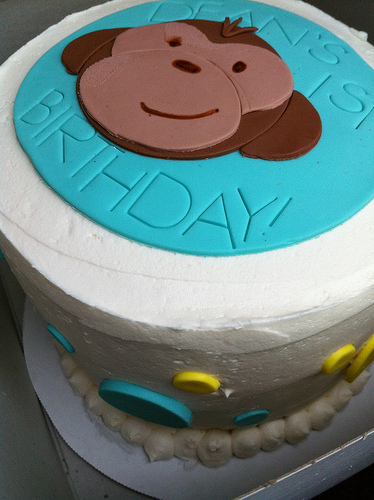<image>
Is there a monkey on the cake? Yes. Looking at the image, I can see the monkey is positioned on top of the cake, with the cake providing support. 